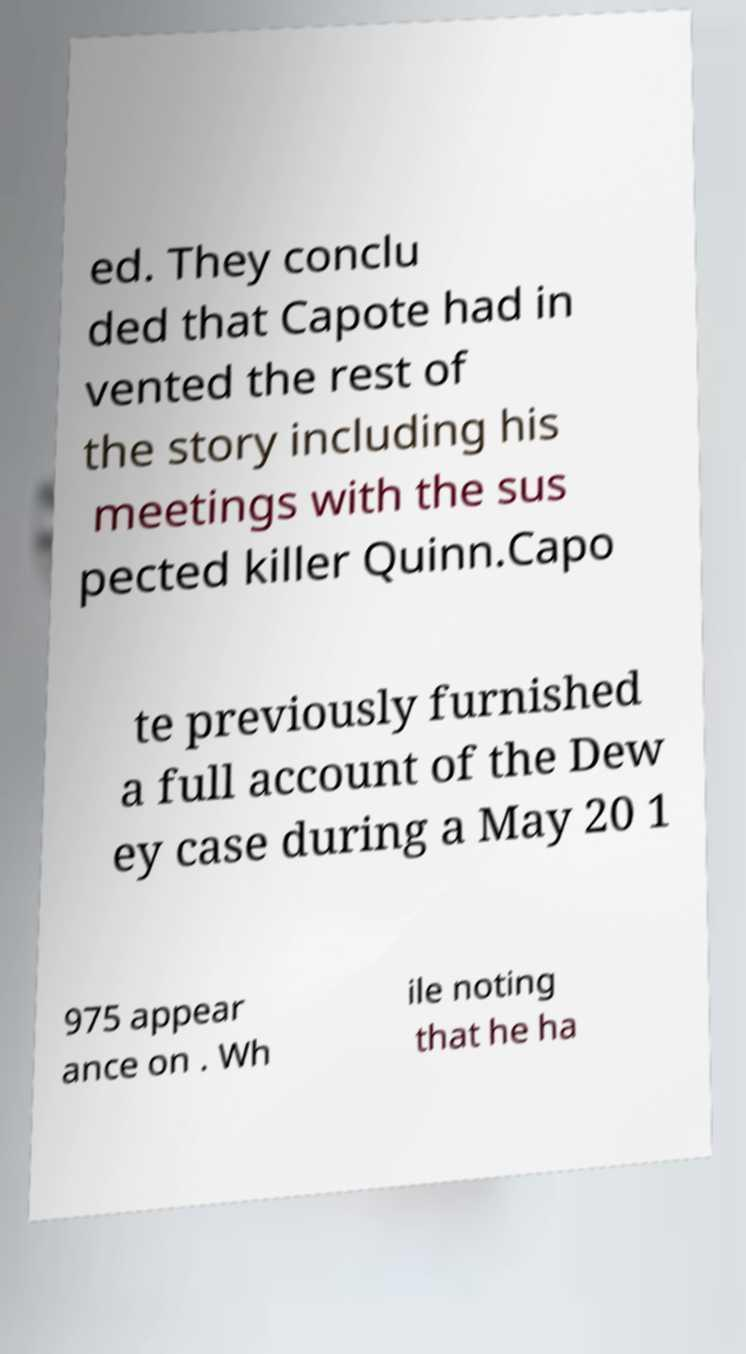For documentation purposes, I need the text within this image transcribed. Could you provide that? ed. They conclu ded that Capote had in vented the rest of the story including his meetings with the sus pected killer Quinn.Capo te previously furnished a full account of the Dew ey case during a May 20 1 975 appear ance on . Wh ile noting that he ha 